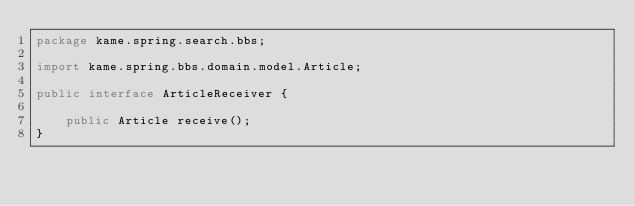Convert code to text. <code><loc_0><loc_0><loc_500><loc_500><_Java_>package kame.spring.search.bbs;

import kame.spring.bbs.domain.model.Article;

public interface ArticleReceiver {

	public Article receive();
}
</code> 